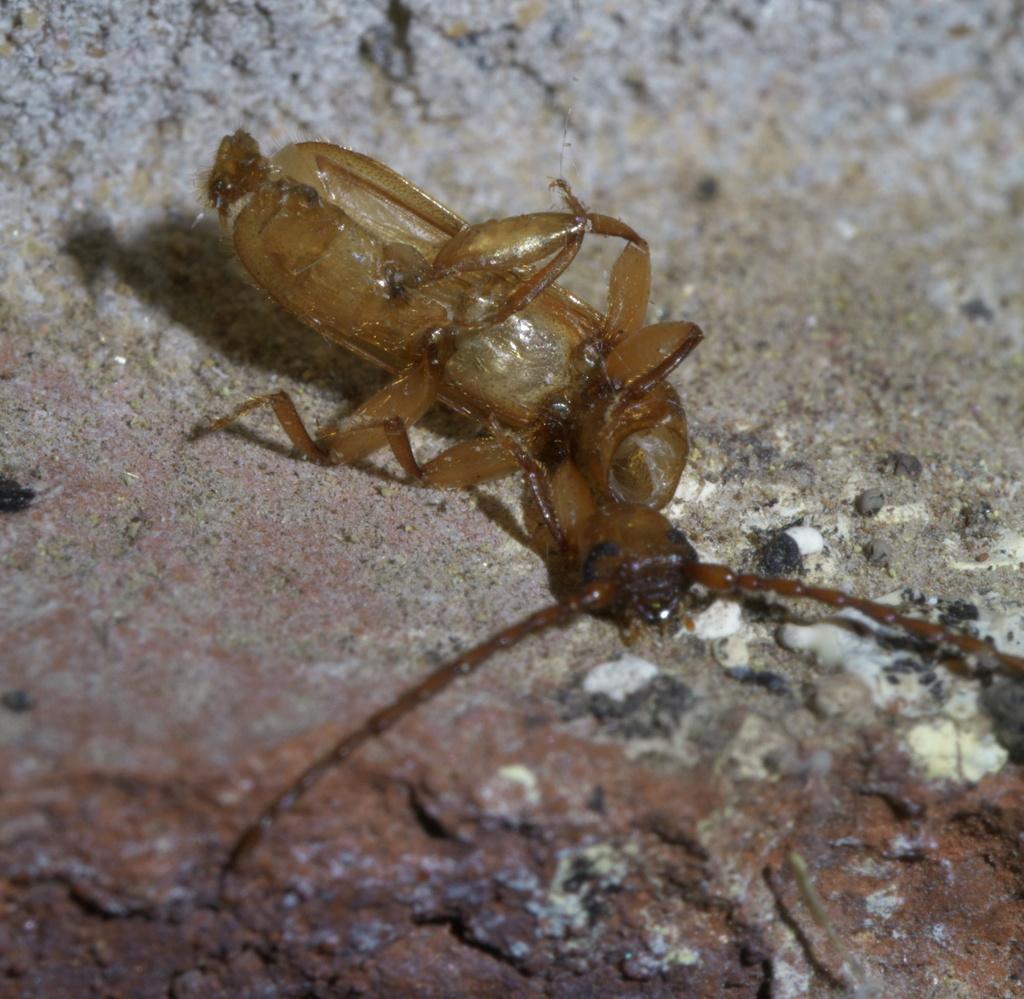Please provide a concise description of this image. In this picture I can see an insect on the rock. 